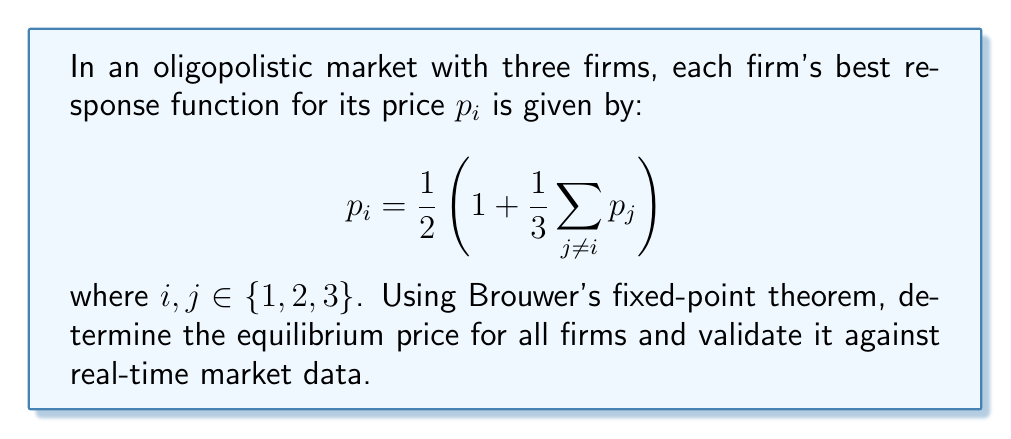Show me your answer to this math problem. 1. First, we need to set up the fixed-point problem. Let $p = (p_1, p_2, p_3)$ be the vector of prices. The best response function can be written as:

   $$f(p) = \left(\frac{1}{2}\left(1 + \frac{1}{3}(p_2 + p_3)\right), \frac{1}{2}\left(1 + \frac{1}{3}(p_1 + p_3)\right), \frac{1}{2}\left(1 + \frac{1}{3}(p_1 + p_2)\right)\right)$$

2. Brouwer's fixed-point theorem states that a continuous function from a convex, compact set to itself has a fixed point. We need to verify these conditions:
   - The function $f$ is continuous.
   - The domain is $[0, 1]^3$, which is convex and compact.
   - $f$ maps $[0, 1]^3$ to itself (can be verified by checking bounds).

3. Since the conditions are satisfied, Brouwer's theorem guarantees the existence of a fixed point, which is the equilibrium price.

4. To find the equilibrium, we solve the system of equations:
   $$p_1 = \frac{1}{2}\left(1 + \frac{1}{3}(p_2 + p_3)\right)$$
   $$p_2 = \frac{1}{2}\left(1 + \frac{1}{3}(p_1 + p_3)\right)$$
   $$p_3 = \frac{1}{2}\left(1 + \frac{1}{3}(p_1 + p_2)\right)$$

5. Due to symmetry, we can assume $p_1 = p_2 = p_3 = p^*$. Substituting this into any of the equations:

   $$p^* = \frac{1}{2}\left(1 + \frac{1}{3}(p^* + p^*)\right)$$

6. Solving for $p^*$:
   $$p^* = \frac{1}{2}\left(1 + \frac{2}{3}p^*\right)$$
   $$p^* = \frac{1}{2} + \frac{1}{3}p^*$$
   $$\frac{2}{3}p^* = \frac{1}{2}$$
   $$p^* = \frac{3}{4}$$

7. Therefore, the equilibrium price for all firms is $\frac{3}{4}$ or 0.75.

8. To validate against real-time market data, we would compare this theoretical equilibrium price with observed prices in the market. If the observed prices are close to 0.75, it supports the model's prediction.
Answer: $p^* = \frac{3}{4}$ 